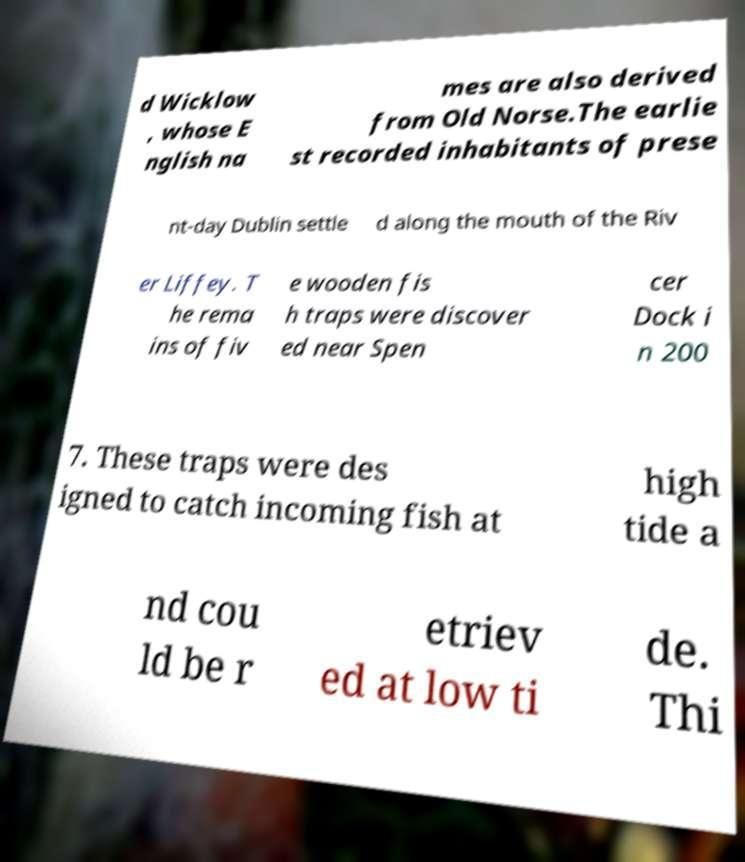Can you read and provide the text displayed in the image?This photo seems to have some interesting text. Can you extract and type it out for me? d Wicklow , whose E nglish na mes are also derived from Old Norse.The earlie st recorded inhabitants of prese nt-day Dublin settle d along the mouth of the Riv er Liffey. T he rema ins of fiv e wooden fis h traps were discover ed near Spen cer Dock i n 200 7. These traps were des igned to catch incoming fish at high tide a nd cou ld be r etriev ed at low ti de. Thi 